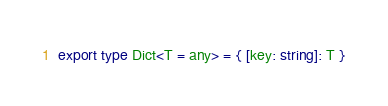<code> <loc_0><loc_0><loc_500><loc_500><_TypeScript_>export type Dict<T = any> = { [key: string]: T }</code> 